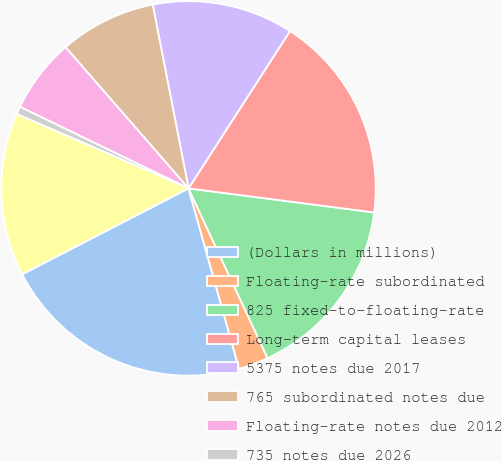Convert chart. <chart><loc_0><loc_0><loc_500><loc_500><pie_chart><fcel>(Dollars in millions)<fcel>Floating-rate subordinated<fcel>825 fixed-to-floating-rate<fcel>Long-term capital leases<fcel>5375 notes due 2017<fcel>765 subordinated notes due<fcel>Floating-rate notes due 2012<fcel>735 notes due 2026<fcel>525 subordinated notes due<nl><fcel>21.76%<fcel>2.59%<fcel>16.01%<fcel>17.93%<fcel>12.18%<fcel>8.34%<fcel>6.42%<fcel>0.67%<fcel>14.09%<nl></chart> 